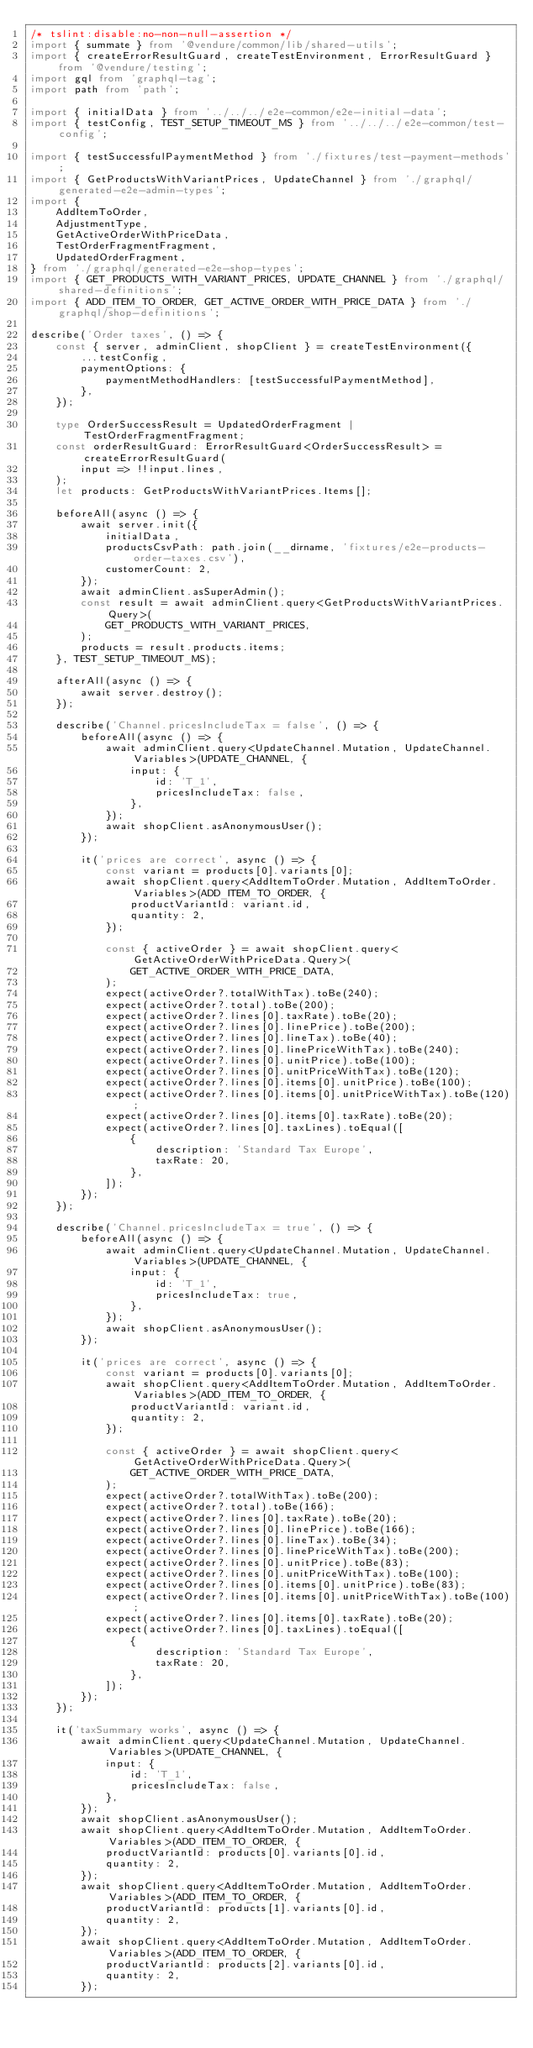Convert code to text. <code><loc_0><loc_0><loc_500><loc_500><_TypeScript_>/* tslint:disable:no-non-null-assertion */
import { summate } from '@vendure/common/lib/shared-utils';
import { createErrorResultGuard, createTestEnvironment, ErrorResultGuard } from '@vendure/testing';
import gql from 'graphql-tag';
import path from 'path';

import { initialData } from '../../../e2e-common/e2e-initial-data';
import { testConfig, TEST_SETUP_TIMEOUT_MS } from '../../../e2e-common/test-config';

import { testSuccessfulPaymentMethod } from './fixtures/test-payment-methods';
import { GetProductsWithVariantPrices, UpdateChannel } from './graphql/generated-e2e-admin-types';
import {
    AddItemToOrder,
    AdjustmentType,
    GetActiveOrderWithPriceData,
    TestOrderFragmentFragment,
    UpdatedOrderFragment,
} from './graphql/generated-e2e-shop-types';
import { GET_PRODUCTS_WITH_VARIANT_PRICES, UPDATE_CHANNEL } from './graphql/shared-definitions';
import { ADD_ITEM_TO_ORDER, GET_ACTIVE_ORDER_WITH_PRICE_DATA } from './graphql/shop-definitions';

describe('Order taxes', () => {
    const { server, adminClient, shopClient } = createTestEnvironment({
        ...testConfig,
        paymentOptions: {
            paymentMethodHandlers: [testSuccessfulPaymentMethod],
        },
    });

    type OrderSuccessResult = UpdatedOrderFragment | TestOrderFragmentFragment;
    const orderResultGuard: ErrorResultGuard<OrderSuccessResult> = createErrorResultGuard(
        input => !!input.lines,
    );
    let products: GetProductsWithVariantPrices.Items[];

    beforeAll(async () => {
        await server.init({
            initialData,
            productsCsvPath: path.join(__dirname, 'fixtures/e2e-products-order-taxes.csv'),
            customerCount: 2,
        });
        await adminClient.asSuperAdmin();
        const result = await adminClient.query<GetProductsWithVariantPrices.Query>(
            GET_PRODUCTS_WITH_VARIANT_PRICES,
        );
        products = result.products.items;
    }, TEST_SETUP_TIMEOUT_MS);

    afterAll(async () => {
        await server.destroy();
    });

    describe('Channel.pricesIncludeTax = false', () => {
        beforeAll(async () => {
            await adminClient.query<UpdateChannel.Mutation, UpdateChannel.Variables>(UPDATE_CHANNEL, {
                input: {
                    id: 'T_1',
                    pricesIncludeTax: false,
                },
            });
            await shopClient.asAnonymousUser();
        });

        it('prices are correct', async () => {
            const variant = products[0].variants[0];
            await shopClient.query<AddItemToOrder.Mutation, AddItemToOrder.Variables>(ADD_ITEM_TO_ORDER, {
                productVariantId: variant.id,
                quantity: 2,
            });

            const { activeOrder } = await shopClient.query<GetActiveOrderWithPriceData.Query>(
                GET_ACTIVE_ORDER_WITH_PRICE_DATA,
            );
            expect(activeOrder?.totalWithTax).toBe(240);
            expect(activeOrder?.total).toBe(200);
            expect(activeOrder?.lines[0].taxRate).toBe(20);
            expect(activeOrder?.lines[0].linePrice).toBe(200);
            expect(activeOrder?.lines[0].lineTax).toBe(40);
            expect(activeOrder?.lines[0].linePriceWithTax).toBe(240);
            expect(activeOrder?.lines[0].unitPrice).toBe(100);
            expect(activeOrder?.lines[0].unitPriceWithTax).toBe(120);
            expect(activeOrder?.lines[0].items[0].unitPrice).toBe(100);
            expect(activeOrder?.lines[0].items[0].unitPriceWithTax).toBe(120);
            expect(activeOrder?.lines[0].items[0].taxRate).toBe(20);
            expect(activeOrder?.lines[0].taxLines).toEqual([
                {
                    description: 'Standard Tax Europe',
                    taxRate: 20,
                },
            ]);
        });
    });

    describe('Channel.pricesIncludeTax = true', () => {
        beforeAll(async () => {
            await adminClient.query<UpdateChannel.Mutation, UpdateChannel.Variables>(UPDATE_CHANNEL, {
                input: {
                    id: 'T_1',
                    pricesIncludeTax: true,
                },
            });
            await shopClient.asAnonymousUser();
        });

        it('prices are correct', async () => {
            const variant = products[0].variants[0];
            await shopClient.query<AddItemToOrder.Mutation, AddItemToOrder.Variables>(ADD_ITEM_TO_ORDER, {
                productVariantId: variant.id,
                quantity: 2,
            });

            const { activeOrder } = await shopClient.query<GetActiveOrderWithPriceData.Query>(
                GET_ACTIVE_ORDER_WITH_PRICE_DATA,
            );
            expect(activeOrder?.totalWithTax).toBe(200);
            expect(activeOrder?.total).toBe(166);
            expect(activeOrder?.lines[0].taxRate).toBe(20);
            expect(activeOrder?.lines[0].linePrice).toBe(166);
            expect(activeOrder?.lines[0].lineTax).toBe(34);
            expect(activeOrder?.lines[0].linePriceWithTax).toBe(200);
            expect(activeOrder?.lines[0].unitPrice).toBe(83);
            expect(activeOrder?.lines[0].unitPriceWithTax).toBe(100);
            expect(activeOrder?.lines[0].items[0].unitPrice).toBe(83);
            expect(activeOrder?.lines[0].items[0].unitPriceWithTax).toBe(100);
            expect(activeOrder?.lines[0].items[0].taxRate).toBe(20);
            expect(activeOrder?.lines[0].taxLines).toEqual([
                {
                    description: 'Standard Tax Europe',
                    taxRate: 20,
                },
            ]);
        });
    });

    it('taxSummary works', async () => {
        await adminClient.query<UpdateChannel.Mutation, UpdateChannel.Variables>(UPDATE_CHANNEL, {
            input: {
                id: 'T_1',
                pricesIncludeTax: false,
            },
        });
        await shopClient.asAnonymousUser();
        await shopClient.query<AddItemToOrder.Mutation, AddItemToOrder.Variables>(ADD_ITEM_TO_ORDER, {
            productVariantId: products[0].variants[0].id,
            quantity: 2,
        });
        await shopClient.query<AddItemToOrder.Mutation, AddItemToOrder.Variables>(ADD_ITEM_TO_ORDER, {
            productVariantId: products[1].variants[0].id,
            quantity: 2,
        });
        await shopClient.query<AddItemToOrder.Mutation, AddItemToOrder.Variables>(ADD_ITEM_TO_ORDER, {
            productVariantId: products[2].variants[0].id,
            quantity: 2,
        });
</code> 